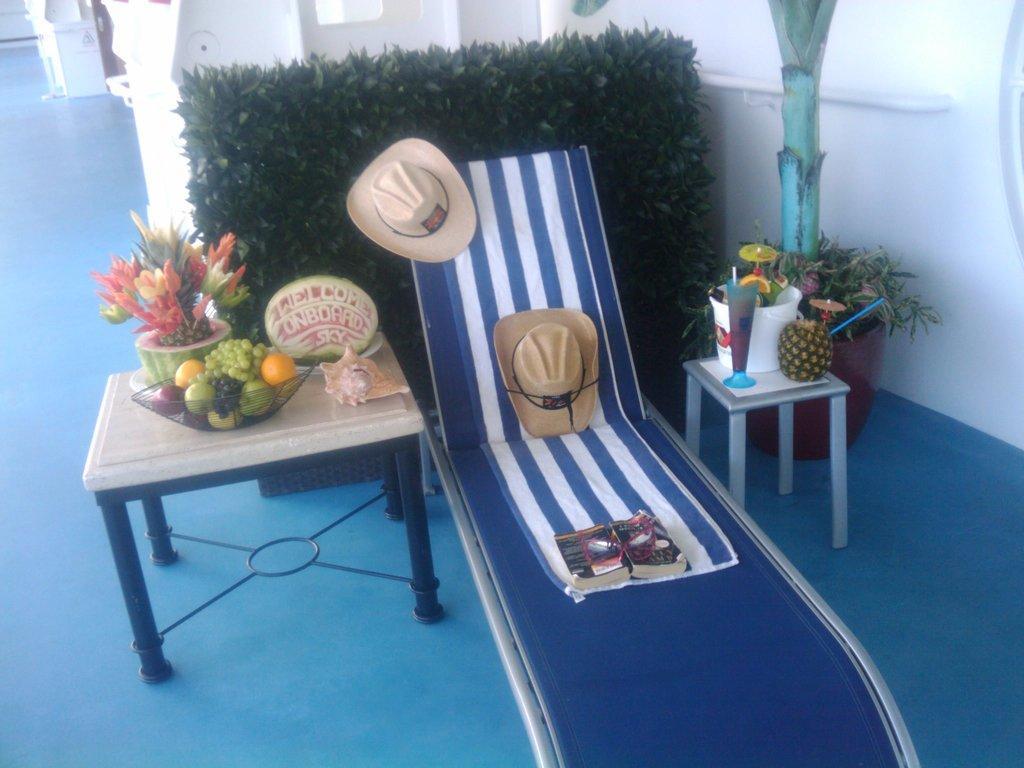Can you describe this image briefly? In this image there are so many things bed,table and chair. The bed and table contains fruits are there and bed contains one book and two hats. 